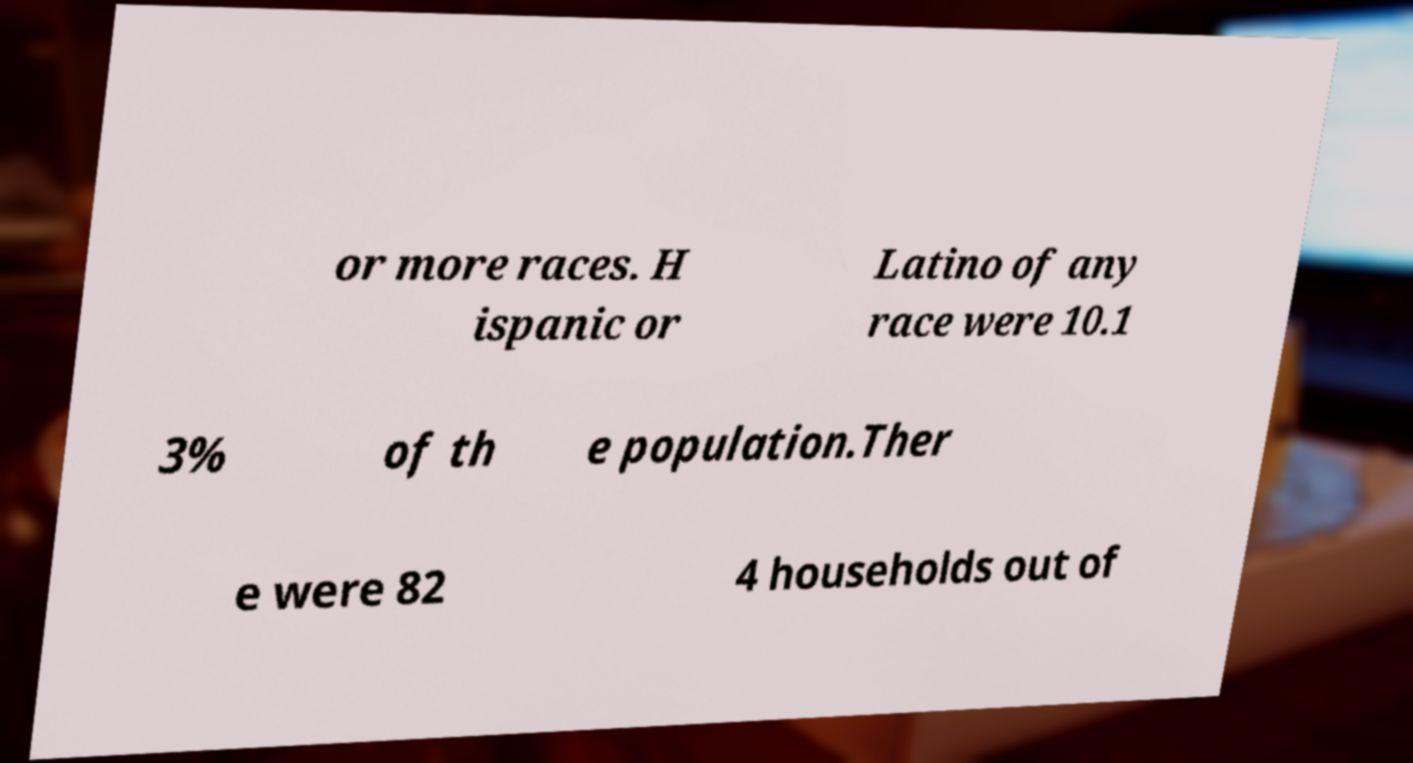Can you accurately transcribe the text from the provided image for me? or more races. H ispanic or Latino of any race were 10.1 3% of th e population.Ther e were 82 4 households out of 